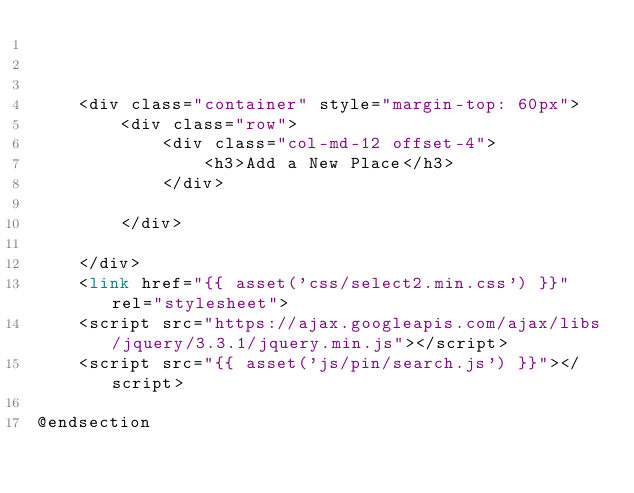Convert code to text. <code><loc_0><loc_0><loc_500><loc_500><_PHP_>


    <div class="container" style="margin-top: 60px">
        <div class="row">
            <div class="col-md-12 offset-4">
                <h3>Add a New Place</h3>
            </div>

        </div>

    </div>
    <link href="{{ asset('css/select2.min.css') }}" rel="stylesheet">
    <script src="https://ajax.googleapis.com/ajax/libs/jquery/3.3.1/jquery.min.js"></script>
    <script src="{{ asset('js/pin/search.js') }}"></script>

@endsection
</code> 